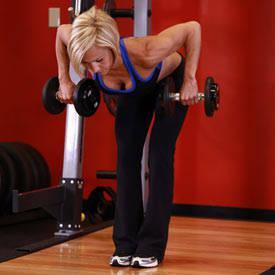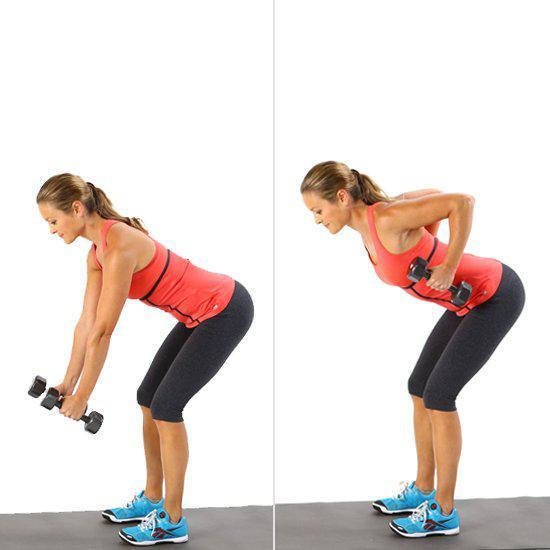The first image is the image on the left, the second image is the image on the right. Considering the images on both sides, is "Each image includes the same number of people, and each person is demonstrating the same type of workout and wearing the same attire." valid? Answer yes or no. No. The first image is the image on the left, the second image is the image on the right. Examine the images to the left and right. Is the description "There are at least two humans in the left image." accurate? Answer yes or no. No. 